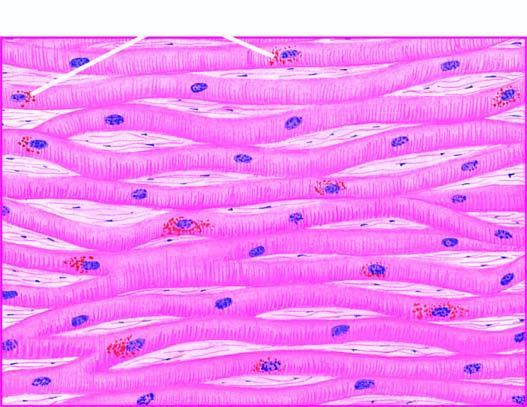re equence of events in the pathogenesis of reversible and irreversible cell injury seen in the cytoplasm of the myocardial fibres, especially around the nuclei?
Answer the question using a single word or phrase. No 